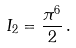<formula> <loc_0><loc_0><loc_500><loc_500>I _ { 2 } = \frac { \pi ^ { 6 } } { 2 } \, .</formula> 